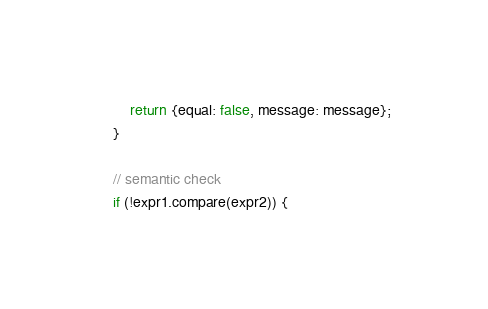Convert code to text. <code><loc_0><loc_0><loc_500><loc_500><_JavaScript_>        return {equal: false, message: message};
    }

    // semantic check
    if (!expr1.compare(expr2)) {</code> 